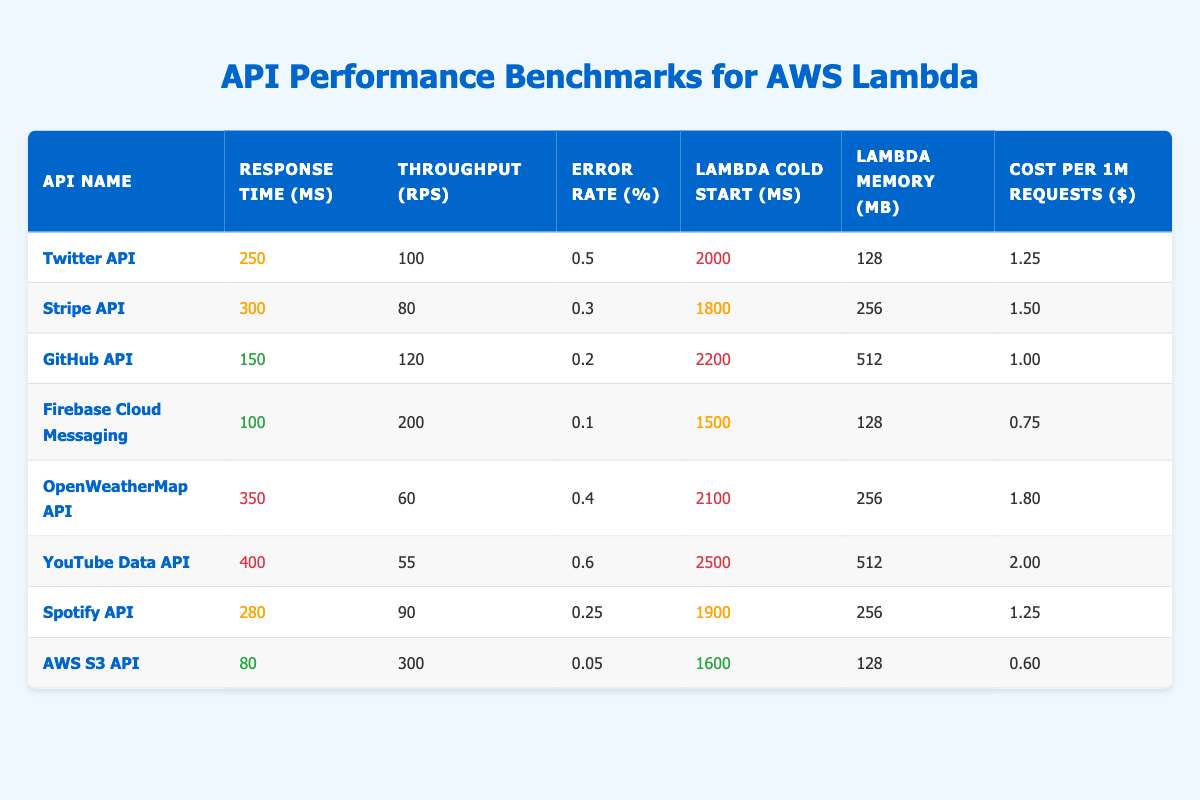What is the response time for the Firebase Cloud Messaging API? The table shows that the response time for Firebase Cloud Messaging is 100 ms.
Answer: 100 ms Which API has the highest throughput, and what is that value? Looking at the "Throughput" column, AWS S3 API has the highest value at 300 requests per second (RPS).
Answer: AWS S3 API, 300 RPS What is the average error rate across all the APIs listed? The error rates for each API are: 0.5, 0.3, 0.2, 0.1, 0.4, 0.6, 0.25, and 0.05. Adding these values gives 2.1, and dividing by 8 (the number of APIs) results in an average error rate of 0.2625, which can be rounded to 0.26%.
Answer: 0.26% Is the error rate for the Spotify API higher than 0.3%? The error rate for the Spotify API is 0.25%, which is lower than 0.3%.
Answer: No What is the cost range for the APIs, and which API is the most expensive? The cost per 1 million requests ranges from $0.60 for AWS S3 API to $2.00 for YouTube Data API. Thus, the most expensive API is YouTube Data API at $2.00.
Answer: YouTube Data API, $2.00 Which API has the best performance rating based on response time? Firebase Cloud Messaging has the lowest response time of 100 ms, indicating it has the best performance in this category.
Answer: Firebase Cloud Messaging Calculate the difference in response times between the fastest and slowest APIs. The fastest API is Firebase Cloud Messaging with 100 ms, and the slowest is YouTube Data API with 400 ms. The difference is 400 - 100 = 300 ms.
Answer: 300 ms Can you identify which API has a Lambda cold start time of 1500 ms? The table shows that Firebase Cloud Messaging has a Lambda cold start time of 1500 ms.
Answer: Firebase Cloud Messaging Which two APIs have similar memory configurations, and what are those configurations? Both Twitter API and AWS S3 API have a Lambda Memory Configuration of 128 MB.
Answer: Twitter API and AWS S3 API, 128 MB If you were to select an API based on minimal error rate and response time, which would you choose? The API with the best metrics is Firebase Cloud Messaging with a 0.1% error rate and a 100 ms response time, leading to it being the optimal choice.
Answer: Firebase Cloud Messaging 